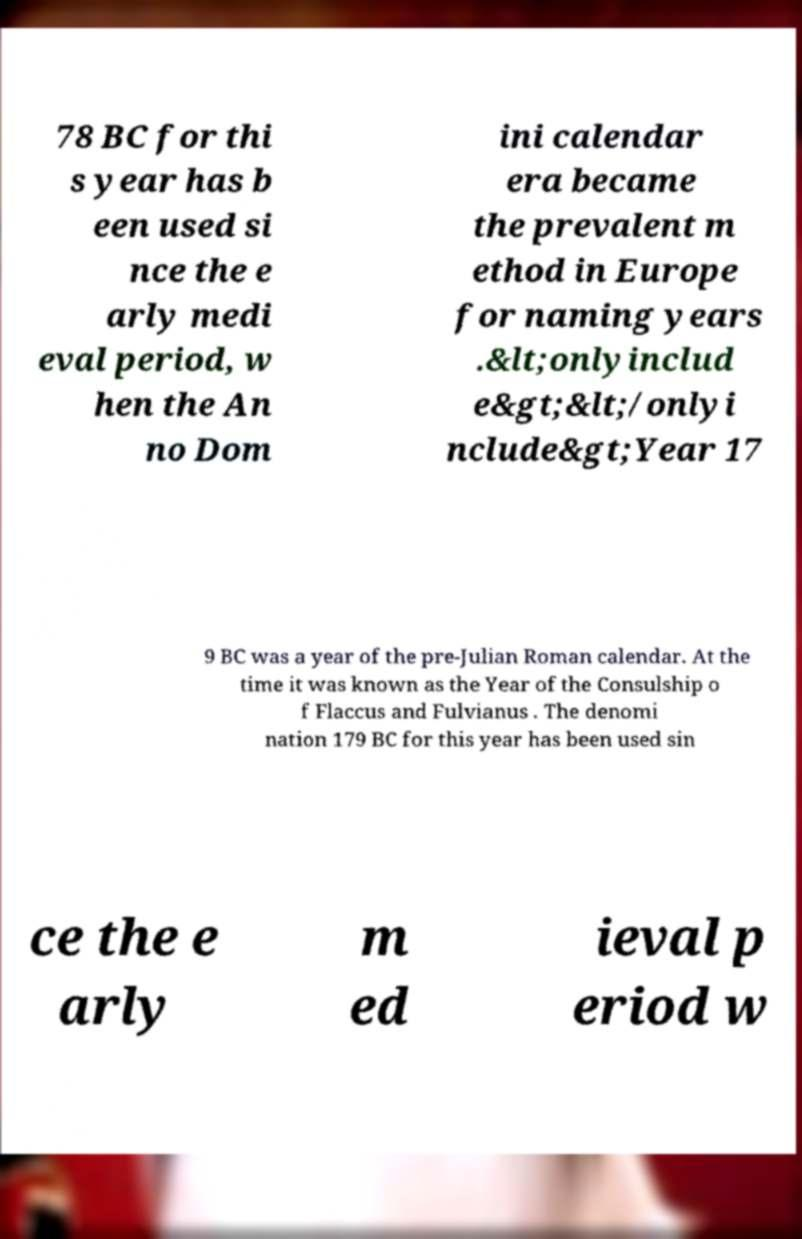For documentation purposes, I need the text within this image transcribed. Could you provide that? 78 BC for thi s year has b een used si nce the e arly medi eval period, w hen the An no Dom ini calendar era became the prevalent m ethod in Europe for naming years .&lt;onlyinclud e&gt;&lt;/onlyi nclude&gt;Year 17 9 BC was a year of the pre-Julian Roman calendar. At the time it was known as the Year of the Consulship o f Flaccus and Fulvianus . The denomi nation 179 BC for this year has been used sin ce the e arly m ed ieval p eriod w 